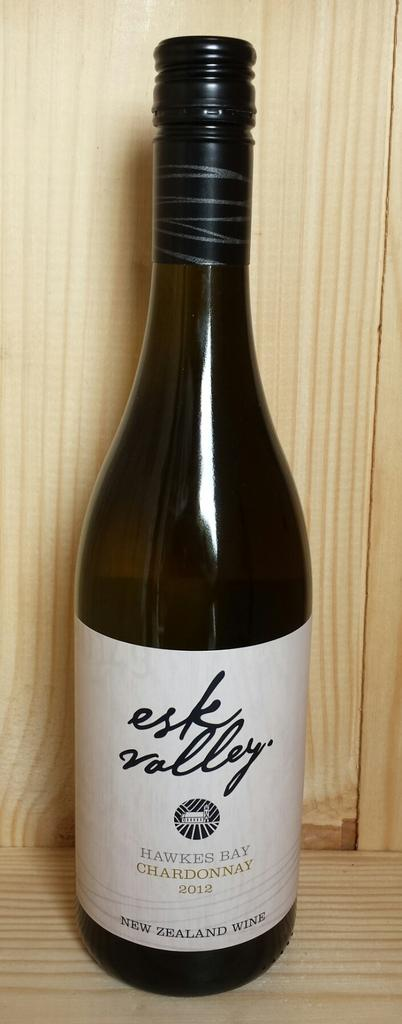<image>
Render a clear and concise summary of the photo. A bottle of New Zealand Wine,  Esk Valley  of 2012. 